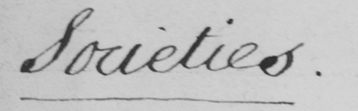Transcribe the text shown in this historical manuscript line. Societies . 